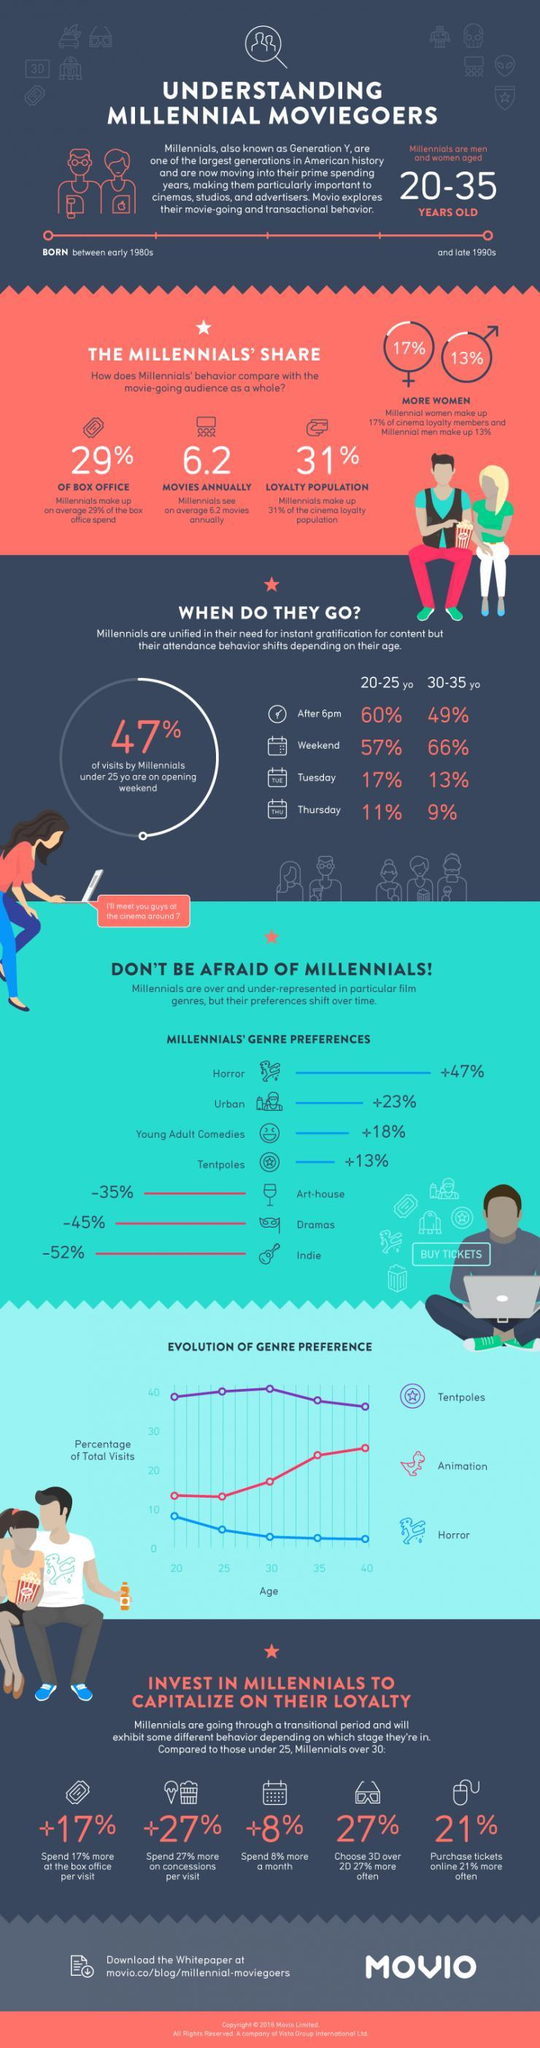What percent of the loyalty population is not millennials?
Answer the question with a short phrase. 69% Which is the most preferred time of the day for 20 to 25 year olds? After 6 pm Which is the least preferred genre of millennials? Indie Which is the favourite genre of millennials? Horror What day/days of the week do 30-35 year old people prefer? Weekend What percent of box office is made up by non-millennials? 71% What percent of millennials prefer urban and young adult comedies? 41% Which gender dominates the cinema loyalty members? Women 